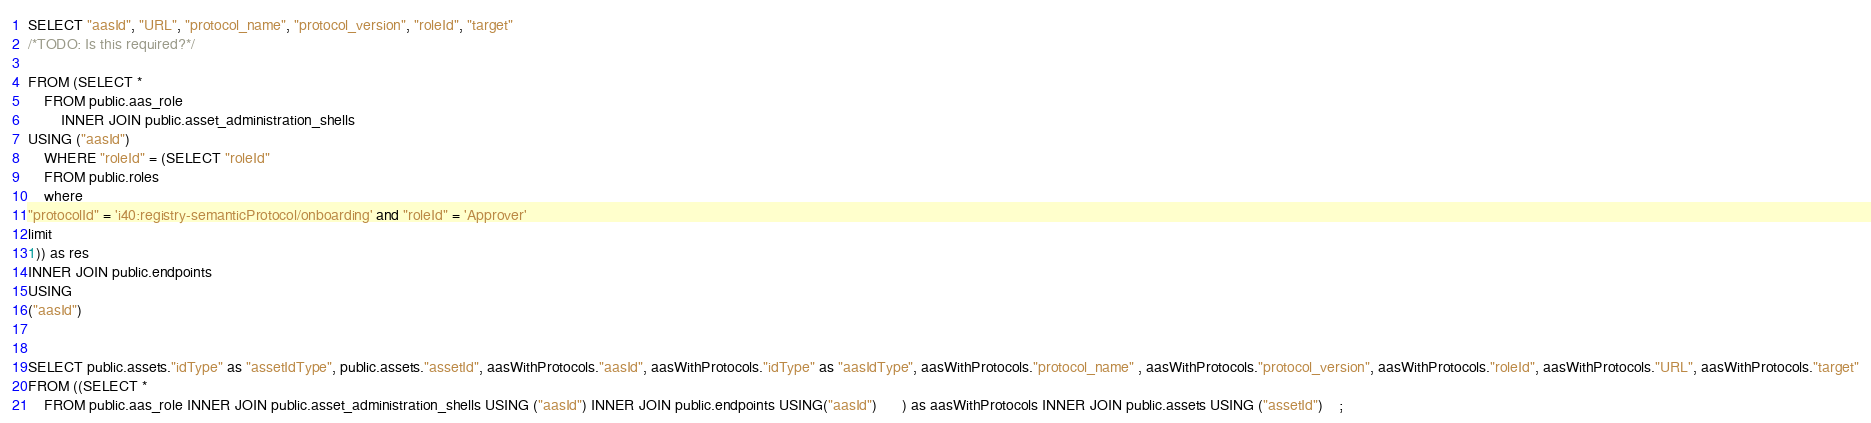Convert code to text. <code><loc_0><loc_0><loc_500><loc_500><_SQL_>
SELECT "aasId", "URL", "protocol_name", "protocol_version", "roleId", "target"
/*TODO: Is this required?*/

FROM (SELECT *
    FROM public.aas_role
        INNER JOIN public.asset_administration_shells
USING ("aasId") 
    WHERE "roleId" = (SELECT "roleId"
    FROM public.roles
    where
"protocolId" = 'i40:registry-semanticProtocol/onboarding' and "roleId" = 'Approver'
limit
1)) as res
INNER JOIN public.endpoints
USING
("aasId")


SELECT public.assets."idType" as "assetIdType", public.assets."assetId", aasWithProtocols."aasId", aasWithProtocols."idType" as "aasIdType", aasWithProtocols."protocol_name" , aasWithProtocols."protocol_version", aasWithProtocols."roleId", aasWithProtocols."URL", aasWithProtocols."target"
FROM ((SELECT *
    FROM public.aas_role INNER JOIN public.asset_administration_shells USING ("aasId") INNER JOIN public.endpoints USING("aasId")      ) as aasWithProtocols INNER JOIN public.assets USING ("assetId")    ;
</code> 